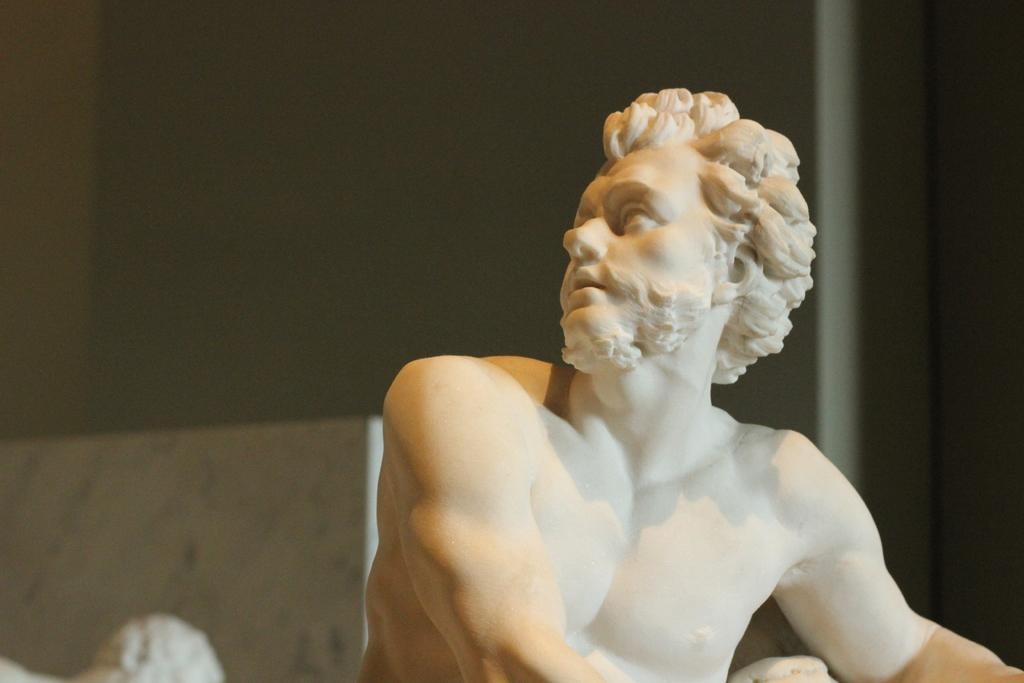What is the main subject of the image? There is a statue of a man in the image. Can you describe the statue's surroundings? There is a wall in the background of the image. What type of hole can be seen in the middle of the statue? There is no hole present in the statue; it is a solid and does not have any openings. 